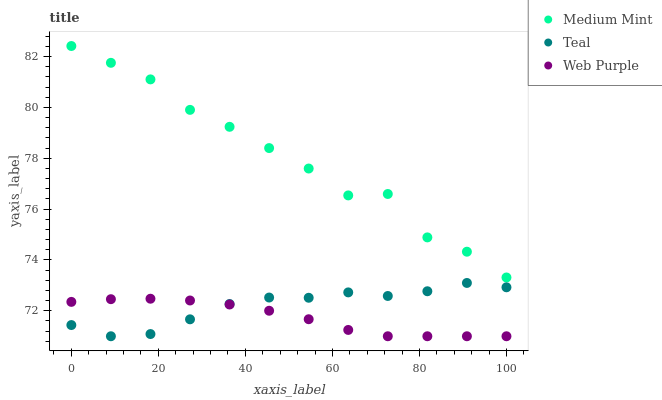Does Web Purple have the minimum area under the curve?
Answer yes or no. Yes. Does Medium Mint have the maximum area under the curve?
Answer yes or no. Yes. Does Teal have the minimum area under the curve?
Answer yes or no. No. Does Teal have the maximum area under the curve?
Answer yes or no. No. Is Web Purple the smoothest?
Answer yes or no. Yes. Is Medium Mint the roughest?
Answer yes or no. Yes. Is Teal the smoothest?
Answer yes or no. No. Is Teal the roughest?
Answer yes or no. No. Does Web Purple have the lowest value?
Answer yes or no. Yes. Does Medium Mint have the highest value?
Answer yes or no. Yes. Does Teal have the highest value?
Answer yes or no. No. Is Teal less than Medium Mint?
Answer yes or no. Yes. Is Medium Mint greater than Web Purple?
Answer yes or no. Yes. Does Teal intersect Web Purple?
Answer yes or no. Yes. Is Teal less than Web Purple?
Answer yes or no. No. Is Teal greater than Web Purple?
Answer yes or no. No. Does Teal intersect Medium Mint?
Answer yes or no. No. 